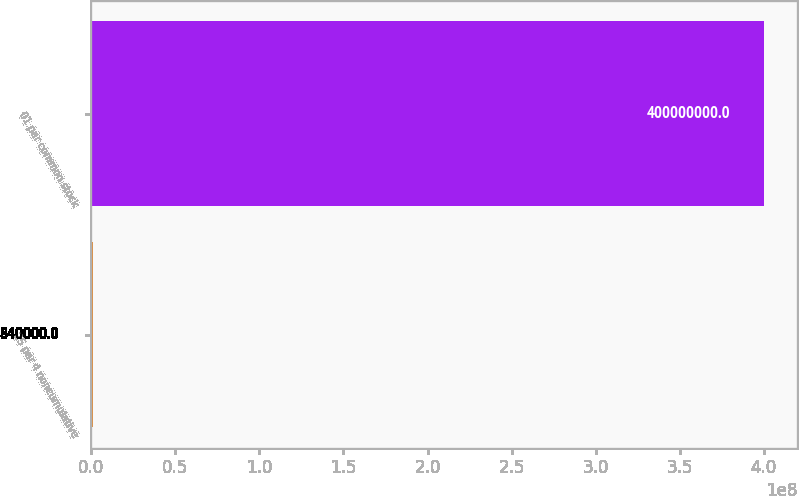<chart> <loc_0><loc_0><loc_500><loc_500><bar_chart><fcel>25 par 4 noncumulative<fcel>01 par common stock<nl><fcel>840000<fcel>4e+08<nl></chart> 